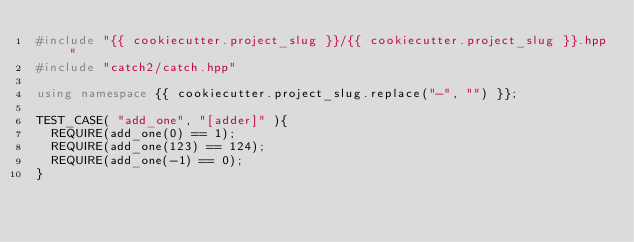<code> <loc_0><loc_0><loc_500><loc_500><_C++_>#include "{{ cookiecutter.project_slug }}/{{ cookiecutter.project_slug }}.hpp"
#include "catch2/catch.hpp"

using namespace {{ cookiecutter.project_slug.replace("-", "") }};

TEST_CASE( "add_one", "[adder]" ){
  REQUIRE(add_one(0) == 1);
  REQUIRE(add_one(123) == 124);
  REQUIRE(add_one(-1) == 0);
}</code> 